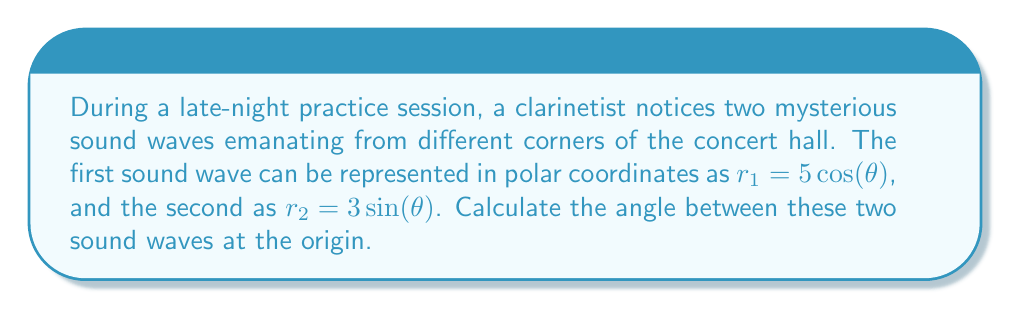Teach me how to tackle this problem. To find the angle between two curves in polar coordinates, we can use the formula:

$$\cos \phi = \frac{r_1 r_2 + (\frac{dr_1}{d\theta})(\frac{dr_2}{d\theta})}{\sqrt{r_1^2 + (\frac{dr_1}{d\theta})^2} \sqrt{r_2^2 + (\frac{dr_2}{d\theta})^2}}$$

Where $\phi$ is the angle between the curves.

Step 1: Find $\frac{dr_1}{d\theta}$ and $\frac{dr_2}{d\theta}$
$r_1 = 5\cos(\theta)$, so $\frac{dr_1}{d\theta} = -5\sin(\theta)$
$r_2 = 3\sin(\theta)$, so $\frac{dr_2}{d\theta} = 3\cos(\theta)$

Step 2: Calculate the numerator
$r_1 r_2 + (\frac{dr_1}{d\theta})(\frac{dr_2}{d\theta}) = 5\cos(\theta) \cdot 3\sin(\theta) + (-5\sin(\theta)) \cdot 3\cos(\theta) = 15\cos(\theta)\sin(\theta) - 15\sin(\theta)\cos(\theta) = 0$

Step 3: Calculate the denominator
$\sqrt{r_1^2 + (\frac{dr_1}{d\theta})^2} = \sqrt{(5\cos(\theta))^2 + (-5\sin(\theta))^2} = \sqrt{25\cos^2(\theta) + 25\sin^2(\theta)} = 5$

$\sqrt{r_2^2 + (\frac{dr_2}{d\theta})^2} = \sqrt{(3\sin(\theta))^2 + (3\cos(\theta))^2} = \sqrt{9\sin^2(\theta) + 9\cos^2(\theta)} = 3$

Step 4: Substitute into the formula
$$\cos \phi = \frac{0}{5 \cdot 3} = 0$$

Step 5: Solve for $\phi$
$\phi = \arccos(0) = \frac{\pi}{2}$

Therefore, the angle between the two sound waves is $\frac{\pi}{2}$ radians or 90 degrees.
Answer: $\frac{\pi}{2}$ radians or 90 degrees 